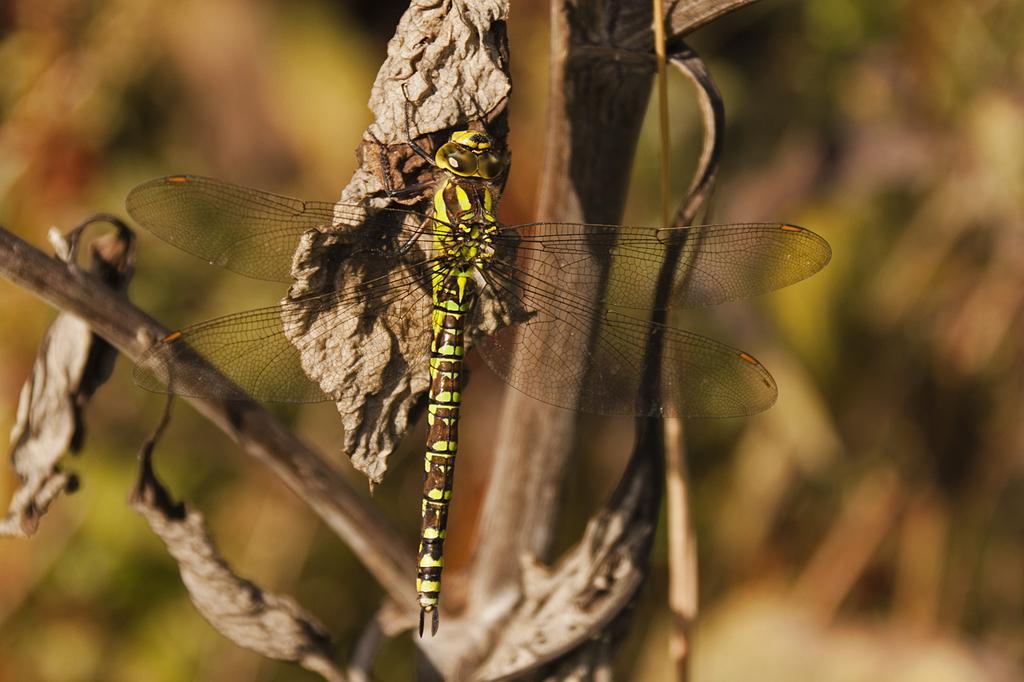Please provide a concise description of this image. In this picture I can observe dragonfly on the dried leaf. This dragonfly is in yellow and brown color. The background is completely blurred. 